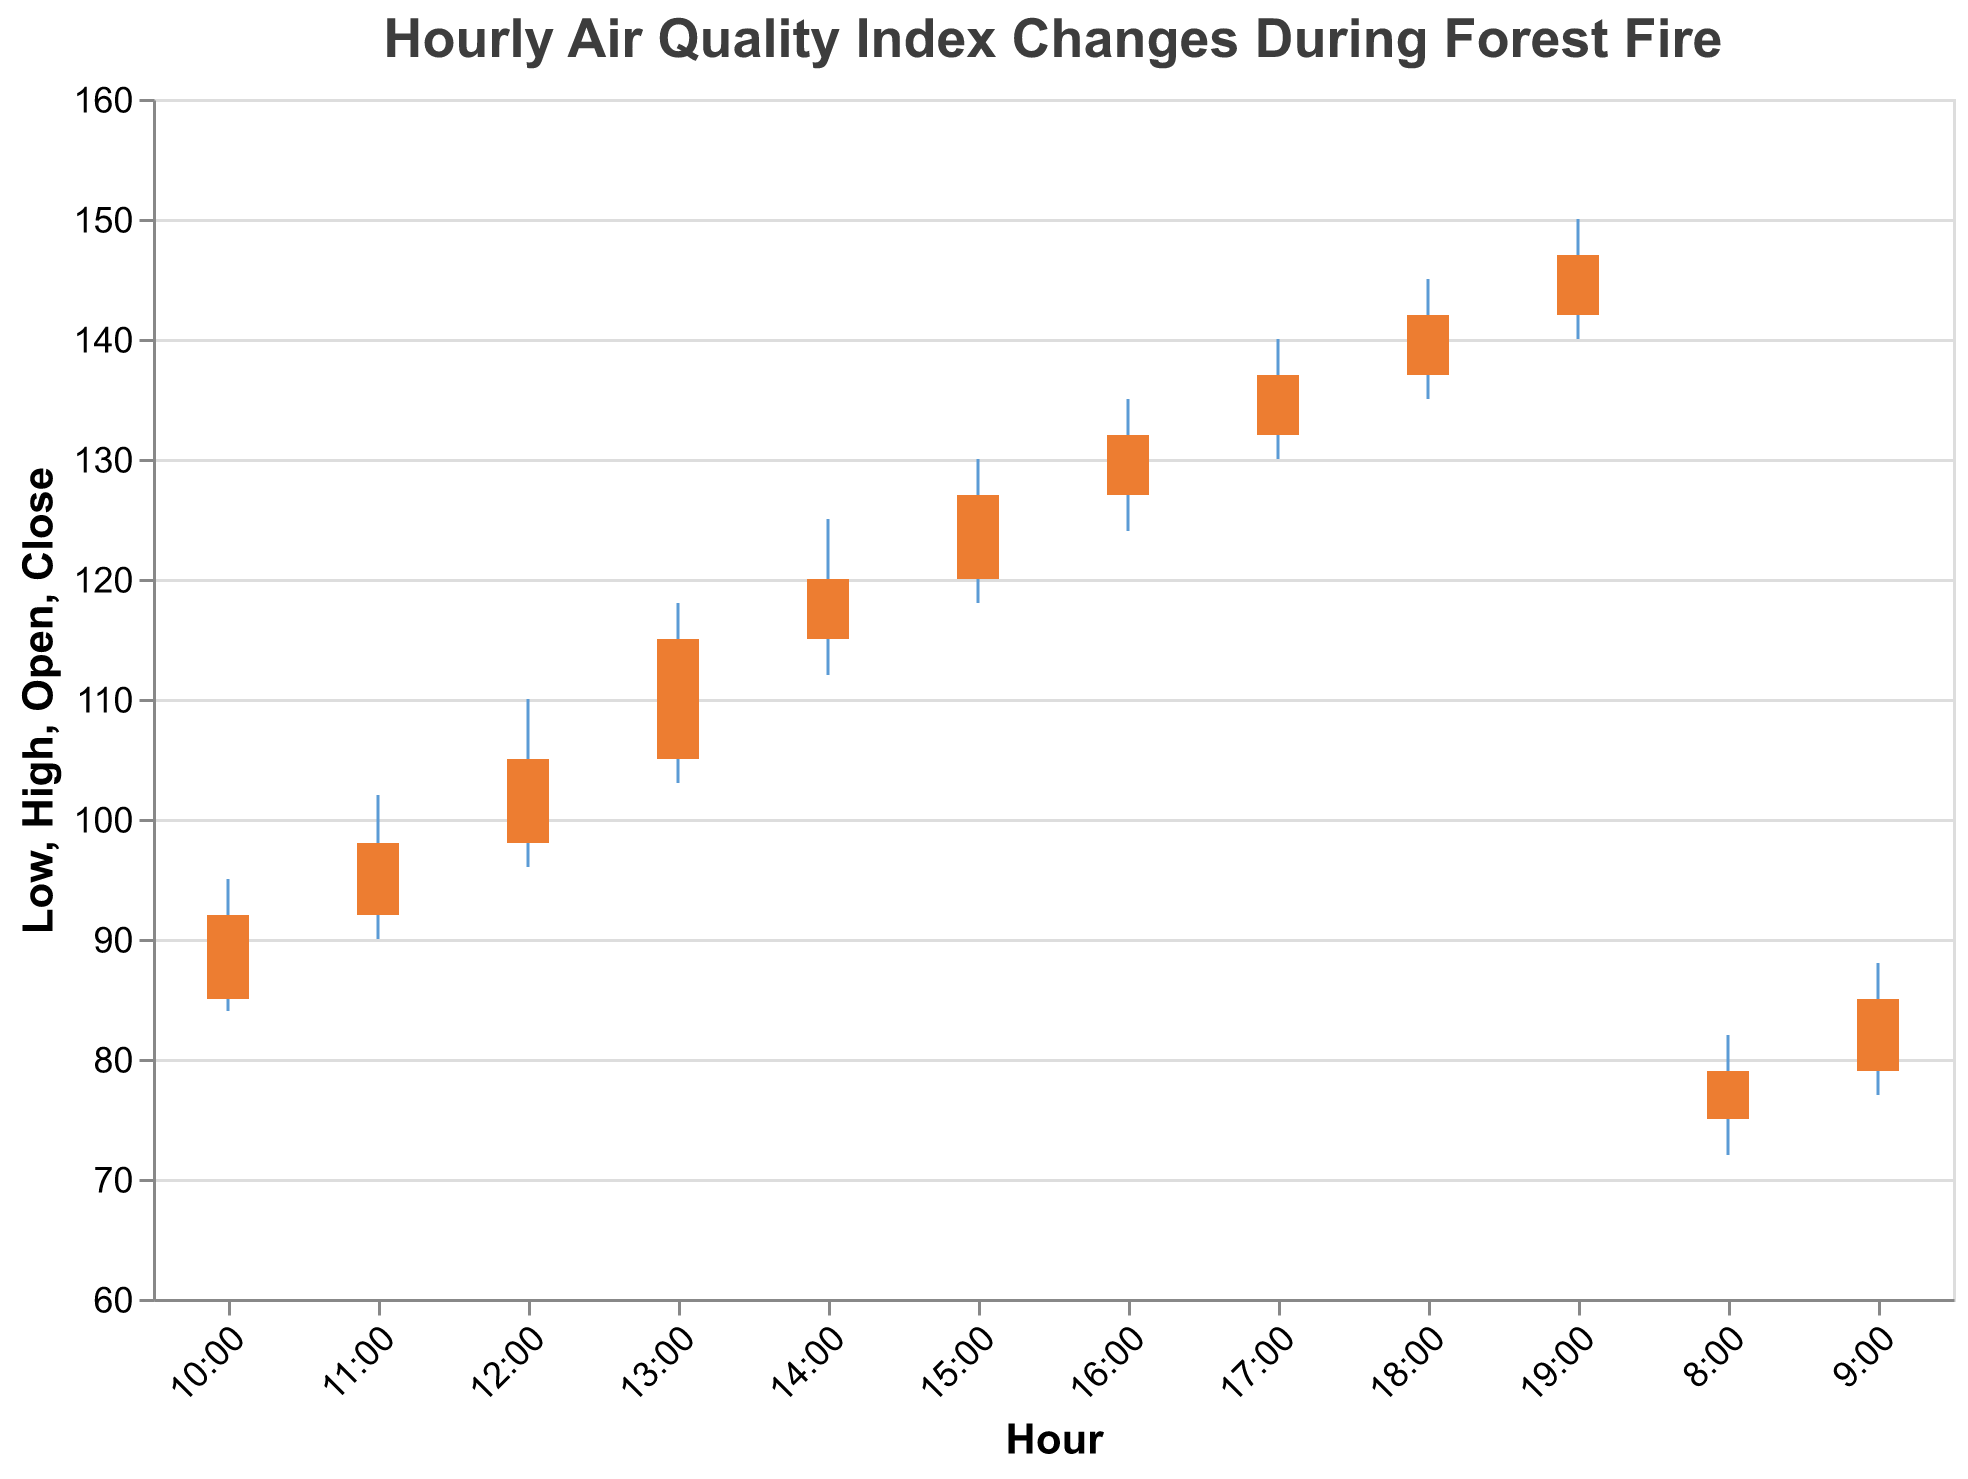What is the title of the chart? The chart's title appears at the top and indicates what the data represents.
Answer: Hourly Air Quality Index Changes During Forest Fire What is the highest air quality index recorded in the chart? The highest point on the y-axis rule line represents the maximum air quality index value. That occurs at 19:00, with a value of 150.
Answer: 150 At what time did the air quality index first exceed 100? Observing the “Close” values, the first time it exceeds 100 is at 12:00, with a value of 105.
Answer: 12:00 What are the opening and closing values at 10:00? Look for the "Open" and "Close" values corresponding to 10:00; the "Open" is 85, and the "Close" is 92.
Answer: Open: 85, Close: 92 How much did the air quality index increase between 13:00 and 14:00? Calculate the difference between the "Close" values at 13:00 (115) and 14:00 (120).
Answer: 5 What was the trend in air quality index from 8:00 to 19:00? Review the general direction of "Close" values starting at 8:00 through 19:00; the overall trend is increasing.
Answer: Increasing Which hour had the lowest recorded air quality index, and what was the value? Check the “Low” values across the timeframe; the lowest value is 72, occurring at 8:00.
Answer: 8:00, 72 Compare the air quality index at 16:00 and 17:00. Which hour had a higher "Close" value? Compare the "Close" values at 16:00 (132) and 17:00 (137); 17:00 is higher.
Answer: 17:00 What is the average of the "Close" values from 10:00 to 12:00? Add the "Close" values from 10:00 (92), 11:00 (98), and 12:00 (105), then divide by 3: (92 + 98 + 105) / 3 = 98.33
Answer: 98.33 What pattern do you see in the "High" values throughout the day? Observe the trend in "High" values from 8:00 (82) upwards to 19:00 (150), indicating a continuous rise.
Answer: Continuous rise 